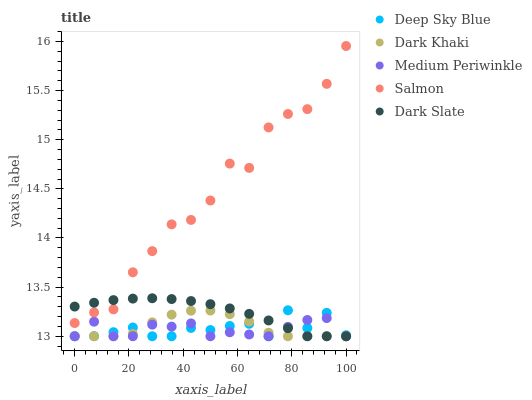Does Medium Periwinkle have the minimum area under the curve?
Answer yes or no. Yes. Does Salmon have the maximum area under the curve?
Answer yes or no. Yes. Does Salmon have the minimum area under the curve?
Answer yes or no. No. Does Medium Periwinkle have the maximum area under the curve?
Answer yes or no. No. Is Dark Slate the smoothest?
Answer yes or no. Yes. Is Salmon the roughest?
Answer yes or no. Yes. Is Medium Periwinkle the smoothest?
Answer yes or no. No. Is Medium Periwinkle the roughest?
Answer yes or no. No. Does Dark Khaki have the lowest value?
Answer yes or no. Yes. Does Salmon have the lowest value?
Answer yes or no. No. Does Salmon have the highest value?
Answer yes or no. Yes. Does Medium Periwinkle have the highest value?
Answer yes or no. No. Is Deep Sky Blue less than Salmon?
Answer yes or no. Yes. Is Salmon greater than Dark Khaki?
Answer yes or no. Yes. Does Medium Periwinkle intersect Dark Khaki?
Answer yes or no. Yes. Is Medium Periwinkle less than Dark Khaki?
Answer yes or no. No. Is Medium Periwinkle greater than Dark Khaki?
Answer yes or no. No. Does Deep Sky Blue intersect Salmon?
Answer yes or no. No. 